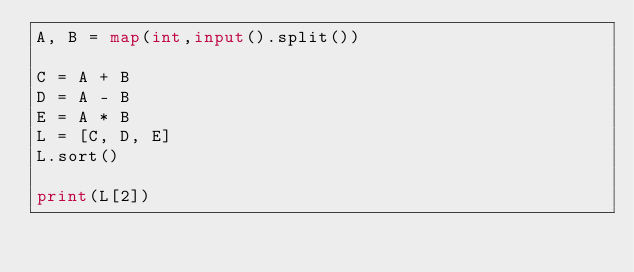Convert code to text. <code><loc_0><loc_0><loc_500><loc_500><_Python_>A, B = map(int,input().split())

C = A + B
D = A - B
E = A * B
L = [C, D, E]
L.sort()

print(L[2])</code> 